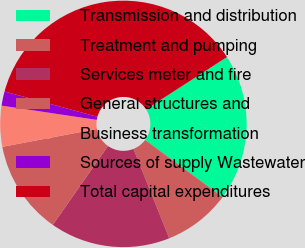Convert chart to OTSL. <chart><loc_0><loc_0><loc_500><loc_500><pie_chart><fcel>Transmission and distribution<fcel>Treatment and pumping<fcel>Services meter and fire<fcel>General structures and<fcel>Business transformation<fcel>Sources of supply Wastewater<fcel>Total capital expenditures<nl><fcel>19.25%<fcel>8.82%<fcel>15.78%<fcel>12.3%<fcel>5.35%<fcel>1.87%<fcel>36.64%<nl></chart> 